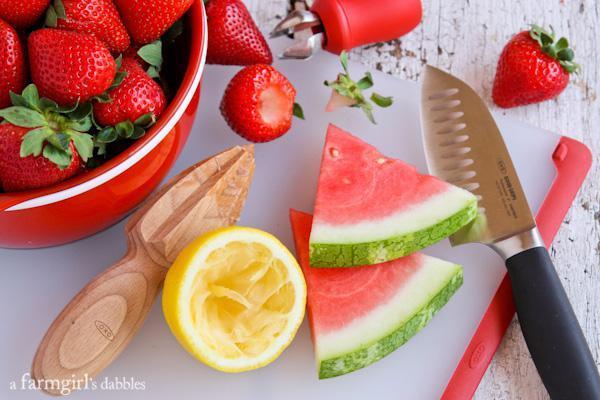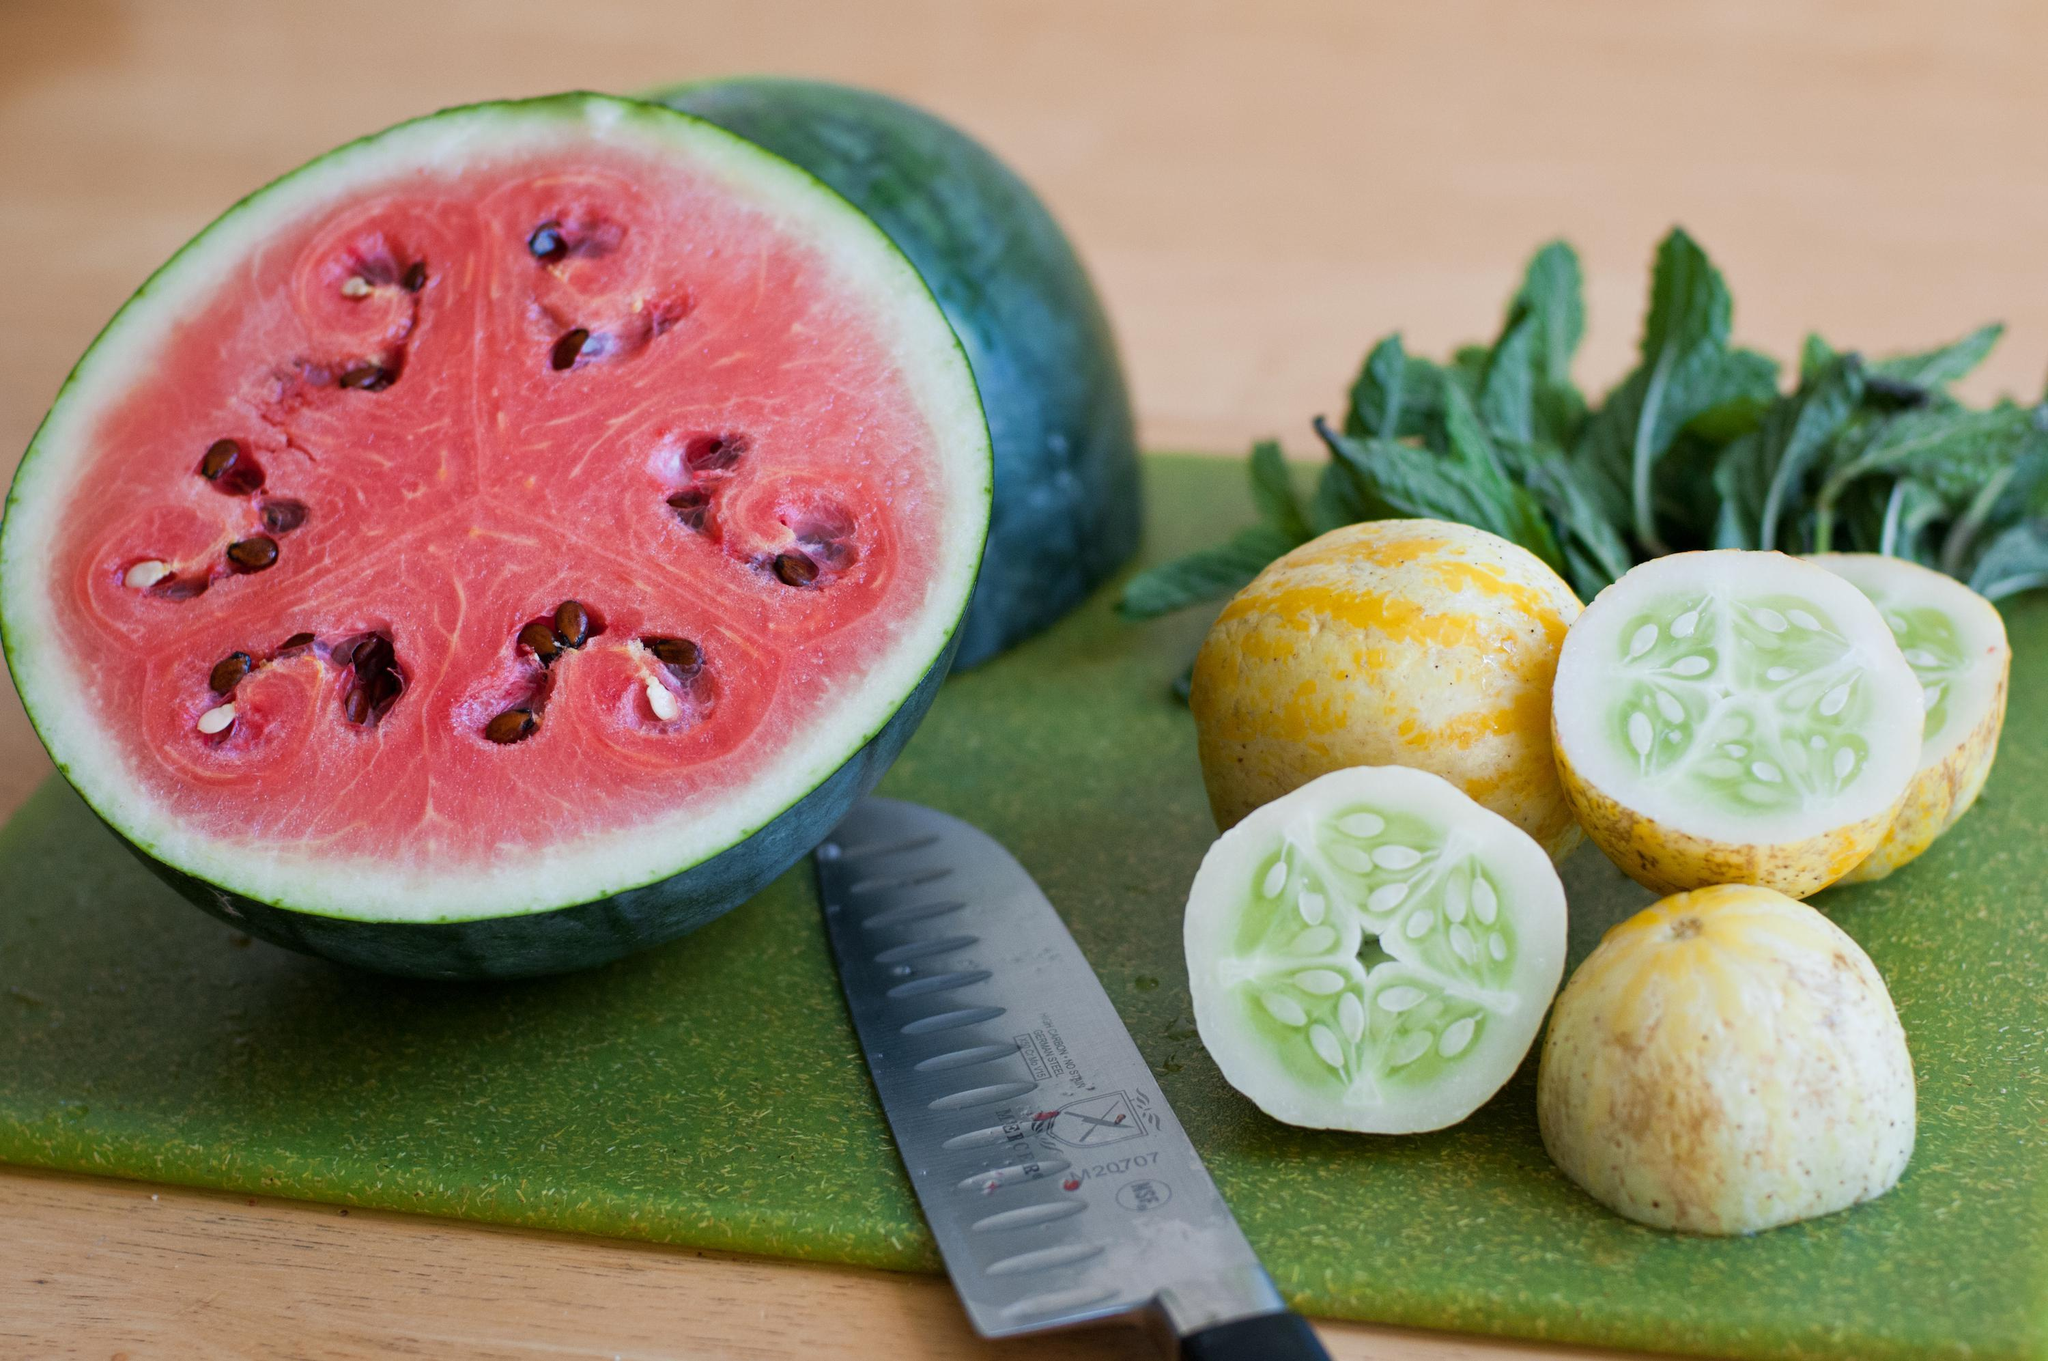The first image is the image on the left, the second image is the image on the right. Analyze the images presented: Is the assertion "In one image, glasses are garnished with lemon pieces." valid? Answer yes or no. No. 